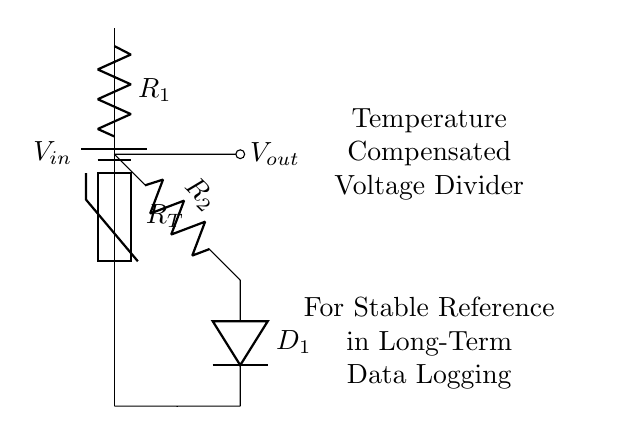What is the input voltage of the circuit? The input voltage is represented by \( V_{in} \), which is indicated next to the battery symbol in the circuit diagram. The battery provides the power supply for the voltage divider.
Answer: \( V_{in} \) What type of component is \( R_{T} \)? \( R_{T} \) is labeled as a thermistor in the diagram. A thermistor is a type of resistor whose resistance varies significantly with temperature, and it is used here for temperature compensation.
Answer: thermistor Which component is used for temperature compensation? The diagram shows that \( R_{T} \) (the thermistor) is specifically used for this purpose as it changes resistance with temperature, thus providing stable output across temperature variations.
Answer: \( R_{T} \) What is \( V_{out} \) connected to? \( V_{out} \) is connected to the node between \( R_1 \) and \( R_T \), which is a common output point for voltage dividers and indicates the output voltage based on the voltage drop across \( R_1 \) as affected by \( R_T \).
Answer: node between \( R_1 \) and \( R_T \) How many resistors are in this voltage divider circuit? The circuit contains two resistors, \( R_1 \) and \( R_2 \), which are critical components of the voltage divider setup to create a stable output voltage.
Answer: two What role does the diode \( D_1 \) play in this circuit? The diode \( D_1 \) is used to ensure current flows in one direction, helping to prevent backflow that could affect the stability of the output voltage in the data logging system.
Answer: current direction control What is the purpose of this circuit? The primary purpose of this circuit, as indicated in the annotations, is to provide a temperature-compensated reference voltage for stable outputs in long-term data logging systems.
Answer: stable reference voltages 